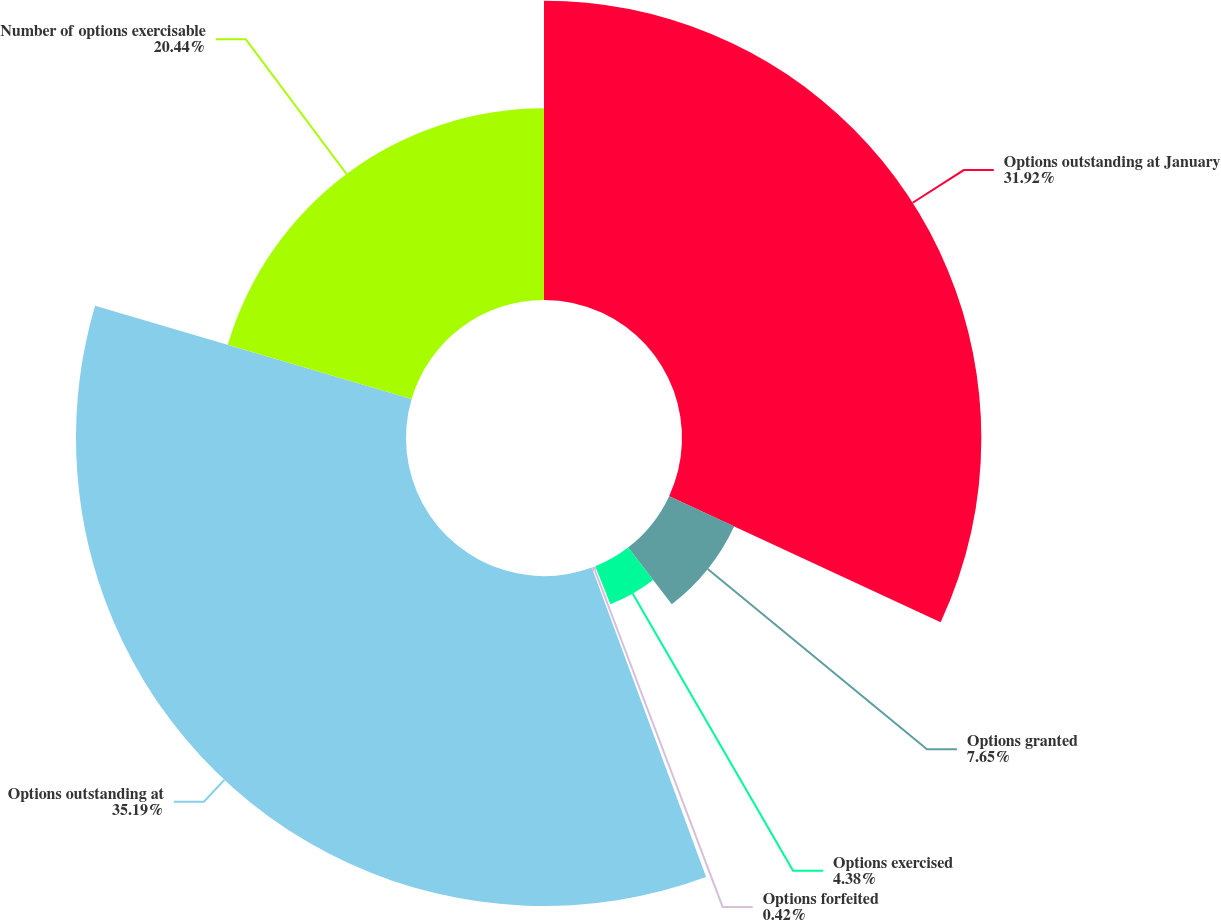Convert chart to OTSL. <chart><loc_0><loc_0><loc_500><loc_500><pie_chart><fcel>Options outstanding at January<fcel>Options granted<fcel>Options exercised<fcel>Options forfeited<fcel>Options outstanding at<fcel>Number of options exercisable<nl><fcel>31.92%<fcel>7.65%<fcel>4.38%<fcel>0.42%<fcel>35.19%<fcel>20.44%<nl></chart> 